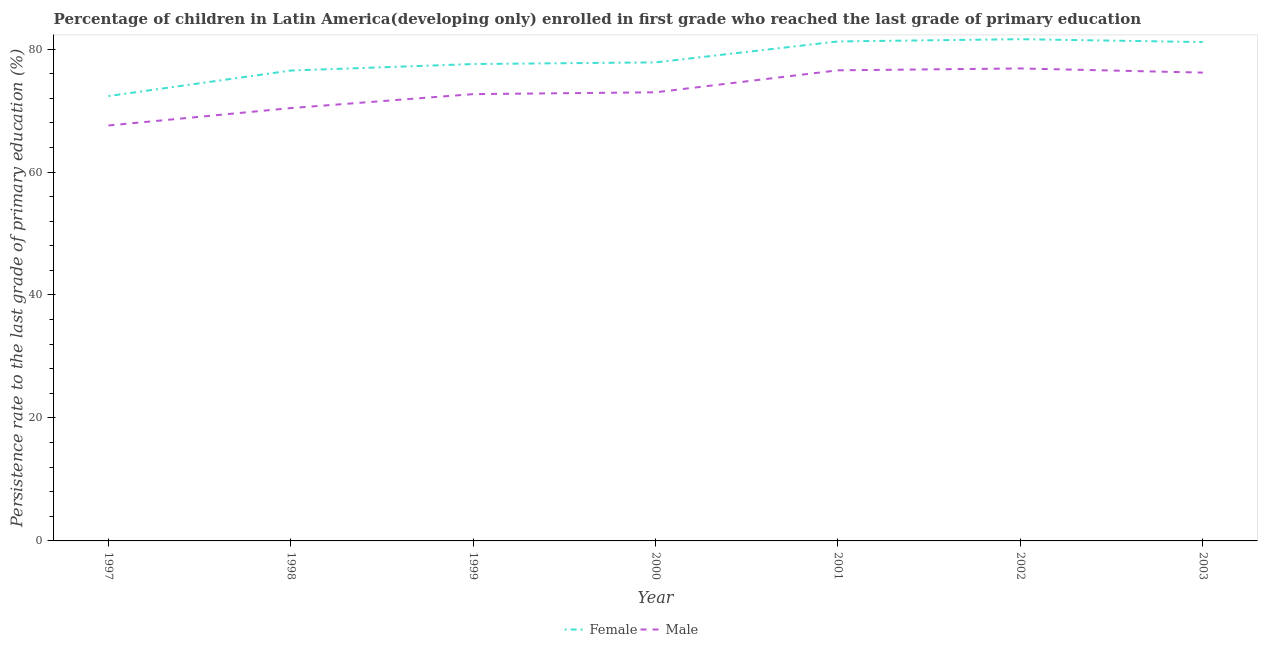How many different coloured lines are there?
Your answer should be compact. 2. What is the persistence rate of male students in 1999?
Provide a succinct answer. 72.67. Across all years, what is the maximum persistence rate of male students?
Make the answer very short. 76.84. Across all years, what is the minimum persistence rate of female students?
Make the answer very short. 72.35. In which year was the persistence rate of male students minimum?
Keep it short and to the point. 1997. What is the total persistence rate of female students in the graph?
Your answer should be compact. 548.22. What is the difference between the persistence rate of female students in 2002 and that in 2003?
Your response must be concise. 0.47. What is the difference between the persistence rate of female students in 2000 and the persistence rate of male students in 1999?
Offer a very short reply. 5.16. What is the average persistence rate of male students per year?
Your answer should be compact. 73.31. In the year 2002, what is the difference between the persistence rate of male students and persistence rate of female students?
Provide a succinct answer. -4.76. In how many years, is the persistence rate of male students greater than 52 %?
Provide a succinct answer. 7. What is the ratio of the persistence rate of female students in 1997 to that in 1999?
Your answer should be very brief. 0.93. Is the persistence rate of female students in 1998 less than that in 2000?
Your response must be concise. Yes. Is the difference between the persistence rate of male students in 1998 and 2003 greater than the difference between the persistence rate of female students in 1998 and 2003?
Make the answer very short. No. What is the difference between the highest and the second highest persistence rate of male students?
Make the answer very short. 0.3. What is the difference between the highest and the lowest persistence rate of female students?
Provide a short and direct response. 9.25. Does the persistence rate of male students monotonically increase over the years?
Ensure brevity in your answer.  No. Is the persistence rate of female students strictly less than the persistence rate of male students over the years?
Ensure brevity in your answer.  No. How many lines are there?
Your answer should be compact. 2. What is the difference between two consecutive major ticks on the Y-axis?
Offer a terse response. 20. Are the values on the major ticks of Y-axis written in scientific E-notation?
Provide a succinct answer. No. Does the graph contain grids?
Give a very brief answer. No. How many legend labels are there?
Provide a short and direct response. 2. How are the legend labels stacked?
Your response must be concise. Horizontal. What is the title of the graph?
Provide a succinct answer. Percentage of children in Latin America(developing only) enrolled in first grade who reached the last grade of primary education. What is the label or title of the X-axis?
Keep it short and to the point. Year. What is the label or title of the Y-axis?
Your response must be concise. Persistence rate to the last grade of primary education (%). What is the Persistence rate to the last grade of primary education (%) of Female in 1997?
Ensure brevity in your answer.  72.35. What is the Persistence rate to the last grade of primary education (%) in Male in 1997?
Provide a short and direct response. 67.57. What is the Persistence rate to the last grade of primary education (%) in Female in 1998?
Provide a short and direct response. 76.5. What is the Persistence rate to the last grade of primary education (%) of Male in 1998?
Keep it short and to the point. 70.4. What is the Persistence rate to the last grade of primary education (%) in Female in 1999?
Your response must be concise. 77.56. What is the Persistence rate to the last grade of primary education (%) in Male in 1999?
Offer a terse response. 72.67. What is the Persistence rate to the last grade of primary education (%) in Female in 2000?
Provide a short and direct response. 77.83. What is the Persistence rate to the last grade of primary education (%) of Male in 2000?
Ensure brevity in your answer.  72.96. What is the Persistence rate to the last grade of primary education (%) in Female in 2001?
Provide a succinct answer. 81.24. What is the Persistence rate to the last grade of primary education (%) in Male in 2001?
Keep it short and to the point. 76.54. What is the Persistence rate to the last grade of primary education (%) of Female in 2002?
Your answer should be very brief. 81.6. What is the Persistence rate to the last grade of primary education (%) in Male in 2002?
Your response must be concise. 76.84. What is the Persistence rate to the last grade of primary education (%) of Female in 2003?
Your answer should be compact. 81.13. What is the Persistence rate to the last grade of primary education (%) of Male in 2003?
Give a very brief answer. 76.17. Across all years, what is the maximum Persistence rate to the last grade of primary education (%) in Female?
Your response must be concise. 81.6. Across all years, what is the maximum Persistence rate to the last grade of primary education (%) in Male?
Provide a short and direct response. 76.84. Across all years, what is the minimum Persistence rate to the last grade of primary education (%) of Female?
Provide a short and direct response. 72.35. Across all years, what is the minimum Persistence rate to the last grade of primary education (%) of Male?
Your answer should be very brief. 67.57. What is the total Persistence rate to the last grade of primary education (%) of Female in the graph?
Provide a short and direct response. 548.22. What is the total Persistence rate to the last grade of primary education (%) of Male in the graph?
Your answer should be very brief. 513.14. What is the difference between the Persistence rate to the last grade of primary education (%) in Female in 1997 and that in 1998?
Give a very brief answer. -4.15. What is the difference between the Persistence rate to the last grade of primary education (%) in Male in 1997 and that in 1998?
Provide a short and direct response. -2.83. What is the difference between the Persistence rate to the last grade of primary education (%) of Female in 1997 and that in 1999?
Offer a terse response. -5.21. What is the difference between the Persistence rate to the last grade of primary education (%) in Male in 1997 and that in 1999?
Give a very brief answer. -5.1. What is the difference between the Persistence rate to the last grade of primary education (%) of Female in 1997 and that in 2000?
Your response must be concise. -5.48. What is the difference between the Persistence rate to the last grade of primary education (%) of Male in 1997 and that in 2000?
Your response must be concise. -5.4. What is the difference between the Persistence rate to the last grade of primary education (%) in Female in 1997 and that in 2001?
Your answer should be very brief. -8.89. What is the difference between the Persistence rate to the last grade of primary education (%) in Male in 1997 and that in 2001?
Make the answer very short. -8.97. What is the difference between the Persistence rate to the last grade of primary education (%) in Female in 1997 and that in 2002?
Provide a short and direct response. -9.25. What is the difference between the Persistence rate to the last grade of primary education (%) in Male in 1997 and that in 2002?
Give a very brief answer. -9.28. What is the difference between the Persistence rate to the last grade of primary education (%) of Female in 1997 and that in 2003?
Your answer should be very brief. -8.78. What is the difference between the Persistence rate to the last grade of primary education (%) in Male in 1997 and that in 2003?
Your answer should be compact. -8.6. What is the difference between the Persistence rate to the last grade of primary education (%) of Female in 1998 and that in 1999?
Offer a very short reply. -1.06. What is the difference between the Persistence rate to the last grade of primary education (%) of Male in 1998 and that in 1999?
Ensure brevity in your answer.  -2.27. What is the difference between the Persistence rate to the last grade of primary education (%) in Female in 1998 and that in 2000?
Make the answer very short. -1.33. What is the difference between the Persistence rate to the last grade of primary education (%) in Male in 1998 and that in 2000?
Make the answer very short. -2.57. What is the difference between the Persistence rate to the last grade of primary education (%) in Female in 1998 and that in 2001?
Offer a terse response. -4.73. What is the difference between the Persistence rate to the last grade of primary education (%) of Male in 1998 and that in 2001?
Provide a short and direct response. -6.14. What is the difference between the Persistence rate to the last grade of primary education (%) of Female in 1998 and that in 2002?
Offer a very short reply. -5.1. What is the difference between the Persistence rate to the last grade of primary education (%) in Male in 1998 and that in 2002?
Your answer should be very brief. -6.45. What is the difference between the Persistence rate to the last grade of primary education (%) in Female in 1998 and that in 2003?
Provide a succinct answer. -4.63. What is the difference between the Persistence rate to the last grade of primary education (%) in Male in 1998 and that in 2003?
Offer a very short reply. -5.77. What is the difference between the Persistence rate to the last grade of primary education (%) of Female in 1999 and that in 2000?
Provide a succinct answer. -0.27. What is the difference between the Persistence rate to the last grade of primary education (%) in Male in 1999 and that in 2000?
Provide a succinct answer. -0.3. What is the difference between the Persistence rate to the last grade of primary education (%) of Female in 1999 and that in 2001?
Your response must be concise. -3.68. What is the difference between the Persistence rate to the last grade of primary education (%) in Male in 1999 and that in 2001?
Offer a very short reply. -3.87. What is the difference between the Persistence rate to the last grade of primary education (%) in Female in 1999 and that in 2002?
Your response must be concise. -4.04. What is the difference between the Persistence rate to the last grade of primary education (%) of Male in 1999 and that in 2002?
Your response must be concise. -4.18. What is the difference between the Persistence rate to the last grade of primary education (%) in Female in 1999 and that in 2003?
Your response must be concise. -3.57. What is the difference between the Persistence rate to the last grade of primary education (%) of Male in 1999 and that in 2003?
Your response must be concise. -3.5. What is the difference between the Persistence rate to the last grade of primary education (%) in Female in 2000 and that in 2001?
Keep it short and to the point. -3.41. What is the difference between the Persistence rate to the last grade of primary education (%) of Male in 2000 and that in 2001?
Provide a succinct answer. -3.58. What is the difference between the Persistence rate to the last grade of primary education (%) of Female in 2000 and that in 2002?
Keep it short and to the point. -3.77. What is the difference between the Persistence rate to the last grade of primary education (%) in Male in 2000 and that in 2002?
Your response must be concise. -3.88. What is the difference between the Persistence rate to the last grade of primary education (%) of Female in 2000 and that in 2003?
Provide a succinct answer. -3.3. What is the difference between the Persistence rate to the last grade of primary education (%) in Male in 2000 and that in 2003?
Keep it short and to the point. -3.2. What is the difference between the Persistence rate to the last grade of primary education (%) in Female in 2001 and that in 2002?
Provide a succinct answer. -0.36. What is the difference between the Persistence rate to the last grade of primary education (%) of Male in 2001 and that in 2002?
Offer a very short reply. -0.3. What is the difference between the Persistence rate to the last grade of primary education (%) in Female in 2001 and that in 2003?
Offer a terse response. 0.1. What is the difference between the Persistence rate to the last grade of primary education (%) in Male in 2001 and that in 2003?
Offer a very short reply. 0.37. What is the difference between the Persistence rate to the last grade of primary education (%) of Female in 2002 and that in 2003?
Your answer should be very brief. 0.47. What is the difference between the Persistence rate to the last grade of primary education (%) in Male in 2002 and that in 2003?
Your response must be concise. 0.68. What is the difference between the Persistence rate to the last grade of primary education (%) in Female in 1997 and the Persistence rate to the last grade of primary education (%) in Male in 1998?
Keep it short and to the point. 1.96. What is the difference between the Persistence rate to the last grade of primary education (%) of Female in 1997 and the Persistence rate to the last grade of primary education (%) of Male in 1999?
Your answer should be compact. -0.31. What is the difference between the Persistence rate to the last grade of primary education (%) in Female in 1997 and the Persistence rate to the last grade of primary education (%) in Male in 2000?
Your answer should be very brief. -0.61. What is the difference between the Persistence rate to the last grade of primary education (%) in Female in 1997 and the Persistence rate to the last grade of primary education (%) in Male in 2001?
Your response must be concise. -4.19. What is the difference between the Persistence rate to the last grade of primary education (%) of Female in 1997 and the Persistence rate to the last grade of primary education (%) of Male in 2002?
Keep it short and to the point. -4.49. What is the difference between the Persistence rate to the last grade of primary education (%) of Female in 1997 and the Persistence rate to the last grade of primary education (%) of Male in 2003?
Make the answer very short. -3.81. What is the difference between the Persistence rate to the last grade of primary education (%) in Female in 1998 and the Persistence rate to the last grade of primary education (%) in Male in 1999?
Give a very brief answer. 3.84. What is the difference between the Persistence rate to the last grade of primary education (%) in Female in 1998 and the Persistence rate to the last grade of primary education (%) in Male in 2000?
Offer a terse response. 3.54. What is the difference between the Persistence rate to the last grade of primary education (%) in Female in 1998 and the Persistence rate to the last grade of primary education (%) in Male in 2001?
Make the answer very short. -0.04. What is the difference between the Persistence rate to the last grade of primary education (%) of Female in 1998 and the Persistence rate to the last grade of primary education (%) of Male in 2002?
Provide a short and direct response. -0.34. What is the difference between the Persistence rate to the last grade of primary education (%) in Female in 1998 and the Persistence rate to the last grade of primary education (%) in Male in 2003?
Keep it short and to the point. 0.34. What is the difference between the Persistence rate to the last grade of primary education (%) of Female in 1999 and the Persistence rate to the last grade of primary education (%) of Male in 2000?
Keep it short and to the point. 4.6. What is the difference between the Persistence rate to the last grade of primary education (%) of Female in 1999 and the Persistence rate to the last grade of primary education (%) of Male in 2002?
Offer a very short reply. 0.72. What is the difference between the Persistence rate to the last grade of primary education (%) of Female in 1999 and the Persistence rate to the last grade of primary education (%) of Male in 2003?
Provide a short and direct response. 1.39. What is the difference between the Persistence rate to the last grade of primary education (%) of Female in 2000 and the Persistence rate to the last grade of primary education (%) of Male in 2001?
Provide a succinct answer. 1.29. What is the difference between the Persistence rate to the last grade of primary education (%) in Female in 2000 and the Persistence rate to the last grade of primary education (%) in Male in 2003?
Ensure brevity in your answer.  1.67. What is the difference between the Persistence rate to the last grade of primary education (%) in Female in 2001 and the Persistence rate to the last grade of primary education (%) in Male in 2002?
Your answer should be compact. 4.39. What is the difference between the Persistence rate to the last grade of primary education (%) in Female in 2001 and the Persistence rate to the last grade of primary education (%) in Male in 2003?
Offer a very short reply. 5.07. What is the difference between the Persistence rate to the last grade of primary education (%) in Female in 2002 and the Persistence rate to the last grade of primary education (%) in Male in 2003?
Give a very brief answer. 5.44. What is the average Persistence rate to the last grade of primary education (%) in Female per year?
Offer a terse response. 78.32. What is the average Persistence rate to the last grade of primary education (%) in Male per year?
Give a very brief answer. 73.31. In the year 1997, what is the difference between the Persistence rate to the last grade of primary education (%) of Female and Persistence rate to the last grade of primary education (%) of Male?
Provide a succinct answer. 4.79. In the year 1998, what is the difference between the Persistence rate to the last grade of primary education (%) of Female and Persistence rate to the last grade of primary education (%) of Male?
Ensure brevity in your answer.  6.11. In the year 1999, what is the difference between the Persistence rate to the last grade of primary education (%) of Female and Persistence rate to the last grade of primary education (%) of Male?
Your answer should be very brief. 4.89. In the year 2000, what is the difference between the Persistence rate to the last grade of primary education (%) in Female and Persistence rate to the last grade of primary education (%) in Male?
Offer a very short reply. 4.87. In the year 2001, what is the difference between the Persistence rate to the last grade of primary education (%) of Female and Persistence rate to the last grade of primary education (%) of Male?
Offer a terse response. 4.7. In the year 2002, what is the difference between the Persistence rate to the last grade of primary education (%) of Female and Persistence rate to the last grade of primary education (%) of Male?
Make the answer very short. 4.76. In the year 2003, what is the difference between the Persistence rate to the last grade of primary education (%) of Female and Persistence rate to the last grade of primary education (%) of Male?
Ensure brevity in your answer.  4.97. What is the ratio of the Persistence rate to the last grade of primary education (%) in Female in 1997 to that in 1998?
Provide a short and direct response. 0.95. What is the ratio of the Persistence rate to the last grade of primary education (%) of Male in 1997 to that in 1998?
Give a very brief answer. 0.96. What is the ratio of the Persistence rate to the last grade of primary education (%) of Female in 1997 to that in 1999?
Make the answer very short. 0.93. What is the ratio of the Persistence rate to the last grade of primary education (%) in Male in 1997 to that in 1999?
Give a very brief answer. 0.93. What is the ratio of the Persistence rate to the last grade of primary education (%) in Female in 1997 to that in 2000?
Offer a very short reply. 0.93. What is the ratio of the Persistence rate to the last grade of primary education (%) of Male in 1997 to that in 2000?
Your response must be concise. 0.93. What is the ratio of the Persistence rate to the last grade of primary education (%) of Female in 1997 to that in 2001?
Provide a succinct answer. 0.89. What is the ratio of the Persistence rate to the last grade of primary education (%) of Male in 1997 to that in 2001?
Offer a very short reply. 0.88. What is the ratio of the Persistence rate to the last grade of primary education (%) of Female in 1997 to that in 2002?
Your answer should be very brief. 0.89. What is the ratio of the Persistence rate to the last grade of primary education (%) in Male in 1997 to that in 2002?
Your answer should be compact. 0.88. What is the ratio of the Persistence rate to the last grade of primary education (%) of Female in 1997 to that in 2003?
Provide a short and direct response. 0.89. What is the ratio of the Persistence rate to the last grade of primary education (%) of Male in 1997 to that in 2003?
Offer a terse response. 0.89. What is the ratio of the Persistence rate to the last grade of primary education (%) of Female in 1998 to that in 1999?
Give a very brief answer. 0.99. What is the ratio of the Persistence rate to the last grade of primary education (%) of Male in 1998 to that in 1999?
Provide a short and direct response. 0.97. What is the ratio of the Persistence rate to the last grade of primary education (%) of Female in 1998 to that in 2000?
Keep it short and to the point. 0.98. What is the ratio of the Persistence rate to the last grade of primary education (%) in Male in 1998 to that in 2000?
Your answer should be compact. 0.96. What is the ratio of the Persistence rate to the last grade of primary education (%) of Female in 1998 to that in 2001?
Offer a terse response. 0.94. What is the ratio of the Persistence rate to the last grade of primary education (%) of Male in 1998 to that in 2001?
Provide a succinct answer. 0.92. What is the ratio of the Persistence rate to the last grade of primary education (%) in Female in 1998 to that in 2002?
Offer a very short reply. 0.94. What is the ratio of the Persistence rate to the last grade of primary education (%) in Male in 1998 to that in 2002?
Offer a terse response. 0.92. What is the ratio of the Persistence rate to the last grade of primary education (%) in Female in 1998 to that in 2003?
Your answer should be compact. 0.94. What is the ratio of the Persistence rate to the last grade of primary education (%) in Male in 1998 to that in 2003?
Make the answer very short. 0.92. What is the ratio of the Persistence rate to the last grade of primary education (%) in Female in 1999 to that in 2000?
Your answer should be very brief. 1. What is the ratio of the Persistence rate to the last grade of primary education (%) of Female in 1999 to that in 2001?
Provide a short and direct response. 0.95. What is the ratio of the Persistence rate to the last grade of primary education (%) of Male in 1999 to that in 2001?
Provide a short and direct response. 0.95. What is the ratio of the Persistence rate to the last grade of primary education (%) in Female in 1999 to that in 2002?
Your response must be concise. 0.95. What is the ratio of the Persistence rate to the last grade of primary education (%) in Male in 1999 to that in 2002?
Keep it short and to the point. 0.95. What is the ratio of the Persistence rate to the last grade of primary education (%) in Female in 1999 to that in 2003?
Make the answer very short. 0.96. What is the ratio of the Persistence rate to the last grade of primary education (%) in Male in 1999 to that in 2003?
Offer a very short reply. 0.95. What is the ratio of the Persistence rate to the last grade of primary education (%) in Female in 2000 to that in 2001?
Offer a very short reply. 0.96. What is the ratio of the Persistence rate to the last grade of primary education (%) in Male in 2000 to that in 2001?
Your answer should be compact. 0.95. What is the ratio of the Persistence rate to the last grade of primary education (%) of Female in 2000 to that in 2002?
Ensure brevity in your answer.  0.95. What is the ratio of the Persistence rate to the last grade of primary education (%) in Male in 2000 to that in 2002?
Give a very brief answer. 0.95. What is the ratio of the Persistence rate to the last grade of primary education (%) of Female in 2000 to that in 2003?
Your answer should be compact. 0.96. What is the ratio of the Persistence rate to the last grade of primary education (%) of Male in 2000 to that in 2003?
Offer a terse response. 0.96. What is the ratio of the Persistence rate to the last grade of primary education (%) in Female in 2001 to that in 2002?
Give a very brief answer. 1. What is the ratio of the Persistence rate to the last grade of primary education (%) in Male in 2001 to that in 2002?
Give a very brief answer. 1. What is the ratio of the Persistence rate to the last grade of primary education (%) of Female in 2001 to that in 2003?
Keep it short and to the point. 1. What is the ratio of the Persistence rate to the last grade of primary education (%) of Male in 2001 to that in 2003?
Keep it short and to the point. 1. What is the ratio of the Persistence rate to the last grade of primary education (%) in Male in 2002 to that in 2003?
Ensure brevity in your answer.  1.01. What is the difference between the highest and the second highest Persistence rate to the last grade of primary education (%) of Female?
Provide a succinct answer. 0.36. What is the difference between the highest and the second highest Persistence rate to the last grade of primary education (%) in Male?
Offer a terse response. 0.3. What is the difference between the highest and the lowest Persistence rate to the last grade of primary education (%) in Female?
Make the answer very short. 9.25. What is the difference between the highest and the lowest Persistence rate to the last grade of primary education (%) in Male?
Offer a terse response. 9.28. 